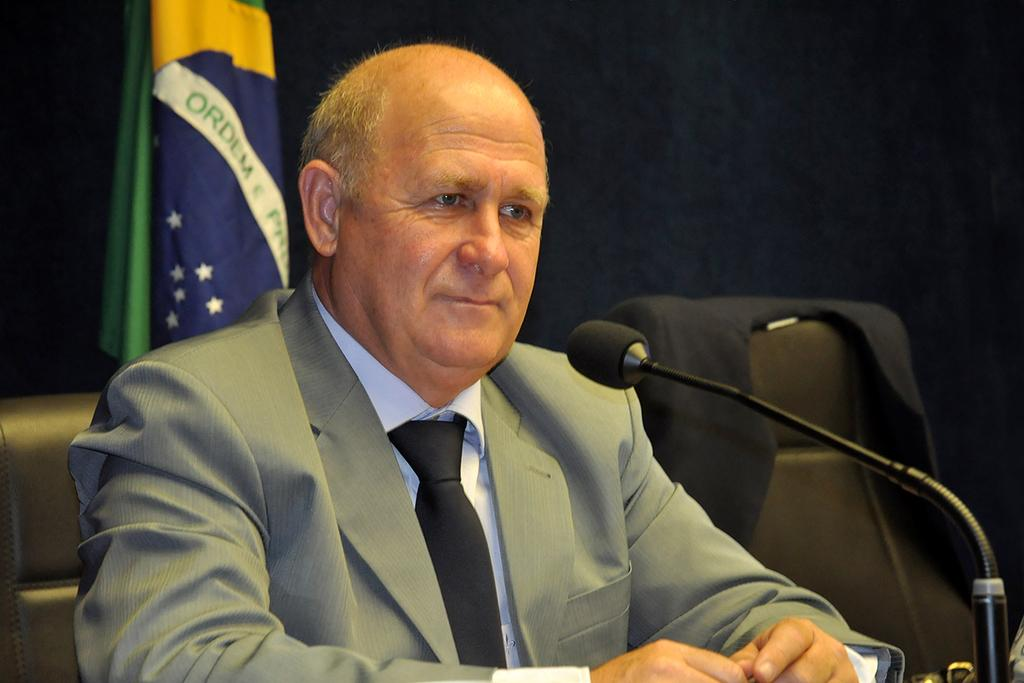What is the man in the image doing? The man is sitting on a chair in the image. What object is on the right side of the image? A microphone is present on the right side of the image. What can be seen in the background of the image? There is a flag and cloth visible in the background of the image. Are there any other chairs in the image besides the one the man is sitting on? Yes, chairs are present in the background of the image. Can you see any bats flying around in the image? There are no bats visible in the image. 